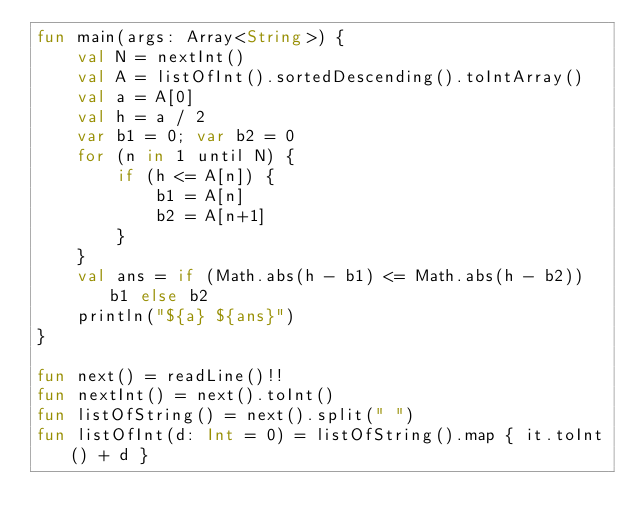<code> <loc_0><loc_0><loc_500><loc_500><_Kotlin_>fun main(args: Array<String>) {
    val N = nextInt()
    val A = listOfInt().sortedDescending().toIntArray()
    val a = A[0]
    val h = a / 2
    var b1 = 0; var b2 = 0
    for (n in 1 until N) {
        if (h <= A[n]) {
            b1 = A[n]
            b2 = A[n+1]
        }
    }
    val ans = if (Math.abs(h - b1) <= Math.abs(h - b2)) b1 else b2
    println("${a} ${ans}")
}

fun next() = readLine()!!
fun nextInt() = next().toInt()
fun listOfString() = next().split(" ")
fun listOfInt(d: Int = 0) = listOfString().map { it.toInt() + d }

</code> 